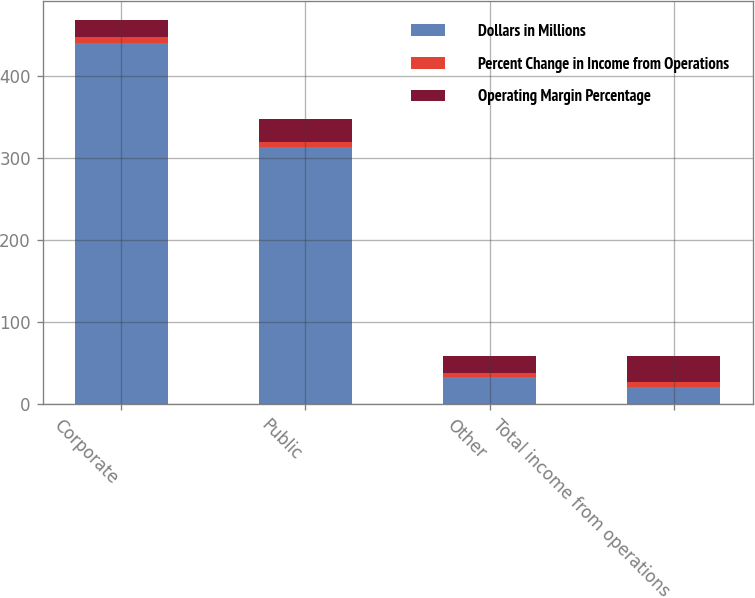<chart> <loc_0><loc_0><loc_500><loc_500><stacked_bar_chart><ecel><fcel>Corporate<fcel>Public<fcel>Other<fcel>Total income from operations<nl><fcel>Dollars in Millions<fcel>439.8<fcel>313.2<fcel>32.9<fcel>21.1<nl><fcel>Percent Change in Income from Operations<fcel>6.8<fcel>6.4<fcel>4.6<fcel>5.6<nl><fcel>Operating Margin Percentage<fcel>21.1<fcel>27.1<fcel>20.9<fcel>32.3<nl></chart> 